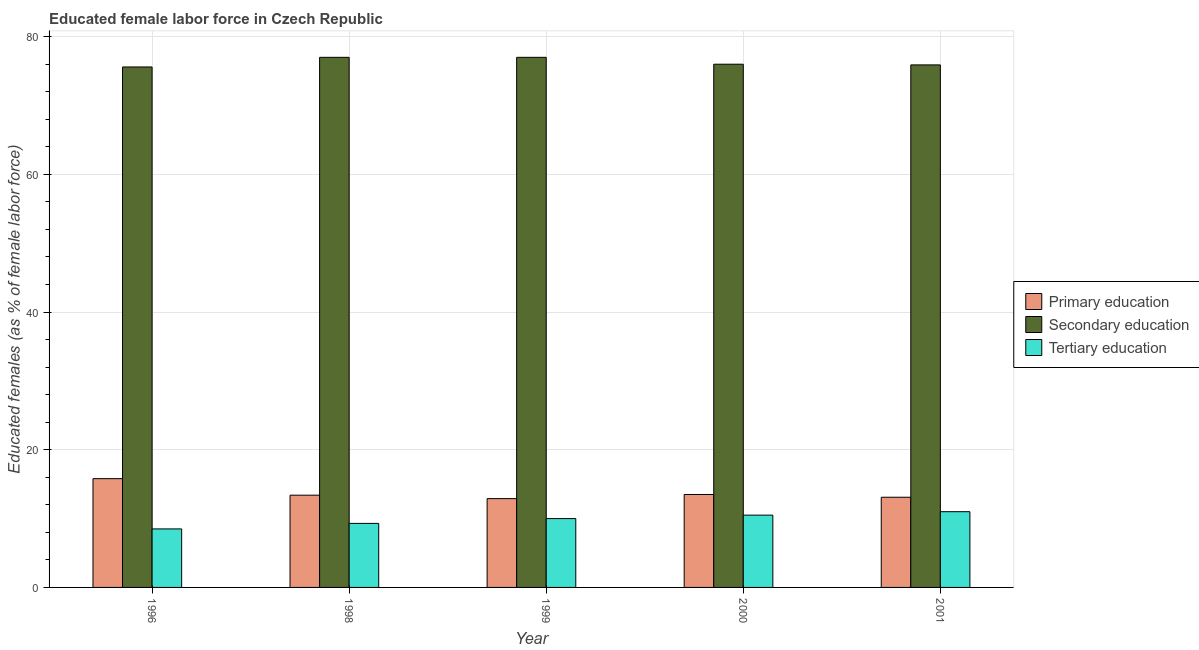How many different coloured bars are there?
Keep it short and to the point. 3. How many groups of bars are there?
Provide a succinct answer. 5. How many bars are there on the 4th tick from the left?
Your answer should be compact. 3. In how many cases, is the number of bars for a given year not equal to the number of legend labels?
Offer a terse response. 0. Across all years, what is the maximum percentage of female labor force who received primary education?
Provide a short and direct response. 15.8. Across all years, what is the minimum percentage of female labor force who received secondary education?
Offer a very short reply. 75.6. What is the total percentage of female labor force who received tertiary education in the graph?
Give a very brief answer. 49.3. What is the difference between the percentage of female labor force who received primary education in 1996 and that in 1998?
Make the answer very short. 2.4. What is the difference between the percentage of female labor force who received tertiary education in 1996 and the percentage of female labor force who received secondary education in 1998?
Your answer should be very brief. -0.8. What is the average percentage of female labor force who received secondary education per year?
Your response must be concise. 76.3. In the year 1996, what is the difference between the percentage of female labor force who received primary education and percentage of female labor force who received tertiary education?
Provide a short and direct response. 0. In how many years, is the percentage of female labor force who received secondary education greater than 16 %?
Give a very brief answer. 5. Is the percentage of female labor force who received primary education in 1999 less than that in 2001?
Ensure brevity in your answer.  Yes. Is the difference between the percentage of female labor force who received secondary education in 1999 and 2001 greater than the difference between the percentage of female labor force who received tertiary education in 1999 and 2001?
Provide a succinct answer. No. What is the difference between the highest and the lowest percentage of female labor force who received tertiary education?
Your response must be concise. 2.5. What does the 2nd bar from the left in 1998 represents?
Your answer should be compact. Secondary education. Are all the bars in the graph horizontal?
Your answer should be very brief. No. Does the graph contain any zero values?
Your response must be concise. No. Where does the legend appear in the graph?
Offer a terse response. Center right. How many legend labels are there?
Your response must be concise. 3. What is the title of the graph?
Provide a short and direct response. Educated female labor force in Czech Republic. Does "Ireland" appear as one of the legend labels in the graph?
Your answer should be compact. No. What is the label or title of the X-axis?
Ensure brevity in your answer.  Year. What is the label or title of the Y-axis?
Provide a short and direct response. Educated females (as % of female labor force). What is the Educated females (as % of female labor force) in Primary education in 1996?
Make the answer very short. 15.8. What is the Educated females (as % of female labor force) in Secondary education in 1996?
Your answer should be compact. 75.6. What is the Educated females (as % of female labor force) of Primary education in 1998?
Keep it short and to the point. 13.4. What is the Educated females (as % of female labor force) of Secondary education in 1998?
Offer a very short reply. 77. What is the Educated females (as % of female labor force) in Tertiary education in 1998?
Your answer should be very brief. 9.3. What is the Educated females (as % of female labor force) of Primary education in 1999?
Provide a succinct answer. 12.9. What is the Educated females (as % of female labor force) of Tertiary education in 1999?
Your answer should be very brief. 10. What is the Educated females (as % of female labor force) of Primary education in 2000?
Your answer should be very brief. 13.5. What is the Educated females (as % of female labor force) of Tertiary education in 2000?
Keep it short and to the point. 10.5. What is the Educated females (as % of female labor force) of Primary education in 2001?
Provide a succinct answer. 13.1. What is the Educated females (as % of female labor force) of Secondary education in 2001?
Ensure brevity in your answer.  75.9. Across all years, what is the maximum Educated females (as % of female labor force) of Primary education?
Your answer should be very brief. 15.8. Across all years, what is the maximum Educated females (as % of female labor force) in Secondary education?
Make the answer very short. 77. Across all years, what is the maximum Educated females (as % of female labor force) of Tertiary education?
Offer a very short reply. 11. Across all years, what is the minimum Educated females (as % of female labor force) in Primary education?
Your response must be concise. 12.9. Across all years, what is the minimum Educated females (as % of female labor force) in Secondary education?
Keep it short and to the point. 75.6. What is the total Educated females (as % of female labor force) in Primary education in the graph?
Offer a terse response. 68.7. What is the total Educated females (as % of female labor force) in Secondary education in the graph?
Your answer should be very brief. 381.5. What is the total Educated females (as % of female labor force) of Tertiary education in the graph?
Offer a very short reply. 49.3. What is the difference between the Educated females (as % of female labor force) in Secondary education in 1996 and that in 1999?
Provide a short and direct response. -1.4. What is the difference between the Educated females (as % of female labor force) in Secondary education in 1996 and that in 2000?
Provide a short and direct response. -0.4. What is the difference between the Educated females (as % of female labor force) of Primary education in 1996 and that in 2001?
Keep it short and to the point. 2.7. What is the difference between the Educated females (as % of female labor force) in Secondary education in 1996 and that in 2001?
Make the answer very short. -0.3. What is the difference between the Educated females (as % of female labor force) of Tertiary education in 1996 and that in 2001?
Your response must be concise. -2.5. What is the difference between the Educated females (as % of female labor force) in Primary education in 1998 and that in 1999?
Ensure brevity in your answer.  0.5. What is the difference between the Educated females (as % of female labor force) in Primary education in 1998 and that in 2000?
Make the answer very short. -0.1. What is the difference between the Educated females (as % of female labor force) in Tertiary education in 1998 and that in 2000?
Ensure brevity in your answer.  -1.2. What is the difference between the Educated females (as % of female labor force) of Secondary education in 1999 and that in 2001?
Provide a short and direct response. 1.1. What is the difference between the Educated females (as % of female labor force) in Tertiary education in 1999 and that in 2001?
Your answer should be compact. -1. What is the difference between the Educated females (as % of female labor force) in Primary education in 2000 and that in 2001?
Provide a succinct answer. 0.4. What is the difference between the Educated females (as % of female labor force) of Tertiary education in 2000 and that in 2001?
Your answer should be very brief. -0.5. What is the difference between the Educated females (as % of female labor force) in Primary education in 1996 and the Educated females (as % of female labor force) in Secondary education in 1998?
Ensure brevity in your answer.  -61.2. What is the difference between the Educated females (as % of female labor force) in Primary education in 1996 and the Educated females (as % of female labor force) in Tertiary education in 1998?
Offer a very short reply. 6.5. What is the difference between the Educated females (as % of female labor force) of Secondary education in 1996 and the Educated females (as % of female labor force) of Tertiary education in 1998?
Offer a very short reply. 66.3. What is the difference between the Educated females (as % of female labor force) in Primary education in 1996 and the Educated females (as % of female labor force) in Secondary education in 1999?
Give a very brief answer. -61.2. What is the difference between the Educated females (as % of female labor force) in Secondary education in 1996 and the Educated females (as % of female labor force) in Tertiary education in 1999?
Your response must be concise. 65.6. What is the difference between the Educated females (as % of female labor force) of Primary education in 1996 and the Educated females (as % of female labor force) of Secondary education in 2000?
Your response must be concise. -60.2. What is the difference between the Educated females (as % of female labor force) in Primary education in 1996 and the Educated females (as % of female labor force) in Tertiary education in 2000?
Ensure brevity in your answer.  5.3. What is the difference between the Educated females (as % of female labor force) of Secondary education in 1996 and the Educated females (as % of female labor force) of Tertiary education in 2000?
Offer a terse response. 65.1. What is the difference between the Educated females (as % of female labor force) in Primary education in 1996 and the Educated females (as % of female labor force) in Secondary education in 2001?
Keep it short and to the point. -60.1. What is the difference between the Educated females (as % of female labor force) in Secondary education in 1996 and the Educated females (as % of female labor force) in Tertiary education in 2001?
Make the answer very short. 64.6. What is the difference between the Educated females (as % of female labor force) of Primary education in 1998 and the Educated females (as % of female labor force) of Secondary education in 1999?
Give a very brief answer. -63.6. What is the difference between the Educated females (as % of female labor force) of Primary education in 1998 and the Educated females (as % of female labor force) of Tertiary education in 1999?
Give a very brief answer. 3.4. What is the difference between the Educated females (as % of female labor force) in Primary education in 1998 and the Educated females (as % of female labor force) in Secondary education in 2000?
Keep it short and to the point. -62.6. What is the difference between the Educated females (as % of female labor force) of Primary education in 1998 and the Educated females (as % of female labor force) of Tertiary education in 2000?
Keep it short and to the point. 2.9. What is the difference between the Educated females (as % of female labor force) in Secondary education in 1998 and the Educated females (as % of female labor force) in Tertiary education in 2000?
Offer a terse response. 66.5. What is the difference between the Educated females (as % of female labor force) in Primary education in 1998 and the Educated females (as % of female labor force) in Secondary education in 2001?
Your answer should be compact. -62.5. What is the difference between the Educated females (as % of female labor force) of Secondary education in 1998 and the Educated females (as % of female labor force) of Tertiary education in 2001?
Ensure brevity in your answer.  66. What is the difference between the Educated females (as % of female labor force) in Primary education in 1999 and the Educated females (as % of female labor force) in Secondary education in 2000?
Ensure brevity in your answer.  -63.1. What is the difference between the Educated females (as % of female labor force) in Primary education in 1999 and the Educated females (as % of female labor force) in Tertiary education in 2000?
Provide a short and direct response. 2.4. What is the difference between the Educated females (as % of female labor force) in Secondary education in 1999 and the Educated females (as % of female labor force) in Tertiary education in 2000?
Offer a terse response. 66.5. What is the difference between the Educated females (as % of female labor force) in Primary education in 1999 and the Educated females (as % of female labor force) in Secondary education in 2001?
Your answer should be very brief. -63. What is the difference between the Educated females (as % of female labor force) of Primary education in 2000 and the Educated females (as % of female labor force) of Secondary education in 2001?
Give a very brief answer. -62.4. What is the difference between the Educated females (as % of female labor force) of Secondary education in 2000 and the Educated females (as % of female labor force) of Tertiary education in 2001?
Provide a short and direct response. 65. What is the average Educated females (as % of female labor force) in Primary education per year?
Provide a short and direct response. 13.74. What is the average Educated females (as % of female labor force) of Secondary education per year?
Your answer should be very brief. 76.3. What is the average Educated females (as % of female labor force) in Tertiary education per year?
Ensure brevity in your answer.  9.86. In the year 1996, what is the difference between the Educated females (as % of female labor force) in Primary education and Educated females (as % of female labor force) in Secondary education?
Offer a very short reply. -59.8. In the year 1996, what is the difference between the Educated females (as % of female labor force) in Secondary education and Educated females (as % of female labor force) in Tertiary education?
Make the answer very short. 67.1. In the year 1998, what is the difference between the Educated females (as % of female labor force) in Primary education and Educated females (as % of female labor force) in Secondary education?
Make the answer very short. -63.6. In the year 1998, what is the difference between the Educated females (as % of female labor force) of Primary education and Educated females (as % of female labor force) of Tertiary education?
Provide a short and direct response. 4.1. In the year 1998, what is the difference between the Educated females (as % of female labor force) in Secondary education and Educated females (as % of female labor force) in Tertiary education?
Your answer should be very brief. 67.7. In the year 1999, what is the difference between the Educated females (as % of female labor force) of Primary education and Educated females (as % of female labor force) of Secondary education?
Provide a succinct answer. -64.1. In the year 1999, what is the difference between the Educated females (as % of female labor force) of Secondary education and Educated females (as % of female labor force) of Tertiary education?
Ensure brevity in your answer.  67. In the year 2000, what is the difference between the Educated females (as % of female labor force) of Primary education and Educated females (as % of female labor force) of Secondary education?
Provide a succinct answer. -62.5. In the year 2000, what is the difference between the Educated females (as % of female labor force) in Primary education and Educated females (as % of female labor force) in Tertiary education?
Your response must be concise. 3. In the year 2000, what is the difference between the Educated females (as % of female labor force) of Secondary education and Educated females (as % of female labor force) of Tertiary education?
Offer a terse response. 65.5. In the year 2001, what is the difference between the Educated females (as % of female labor force) in Primary education and Educated females (as % of female labor force) in Secondary education?
Keep it short and to the point. -62.8. In the year 2001, what is the difference between the Educated females (as % of female labor force) of Secondary education and Educated females (as % of female labor force) of Tertiary education?
Ensure brevity in your answer.  64.9. What is the ratio of the Educated females (as % of female labor force) of Primary education in 1996 to that in 1998?
Your response must be concise. 1.18. What is the ratio of the Educated females (as % of female labor force) in Secondary education in 1996 to that in 1998?
Your response must be concise. 0.98. What is the ratio of the Educated females (as % of female labor force) of Tertiary education in 1996 to that in 1998?
Provide a succinct answer. 0.91. What is the ratio of the Educated females (as % of female labor force) in Primary education in 1996 to that in 1999?
Provide a succinct answer. 1.22. What is the ratio of the Educated females (as % of female labor force) of Secondary education in 1996 to that in 1999?
Provide a short and direct response. 0.98. What is the ratio of the Educated females (as % of female labor force) of Primary education in 1996 to that in 2000?
Offer a very short reply. 1.17. What is the ratio of the Educated females (as % of female labor force) in Tertiary education in 1996 to that in 2000?
Provide a short and direct response. 0.81. What is the ratio of the Educated females (as % of female labor force) of Primary education in 1996 to that in 2001?
Ensure brevity in your answer.  1.21. What is the ratio of the Educated females (as % of female labor force) in Tertiary education in 1996 to that in 2001?
Ensure brevity in your answer.  0.77. What is the ratio of the Educated females (as % of female labor force) of Primary education in 1998 to that in 1999?
Offer a terse response. 1.04. What is the ratio of the Educated females (as % of female labor force) of Secondary education in 1998 to that in 2000?
Provide a succinct answer. 1.01. What is the ratio of the Educated females (as % of female labor force) in Tertiary education in 1998 to that in 2000?
Give a very brief answer. 0.89. What is the ratio of the Educated females (as % of female labor force) in Primary education in 1998 to that in 2001?
Provide a short and direct response. 1.02. What is the ratio of the Educated females (as % of female labor force) in Secondary education in 1998 to that in 2001?
Your answer should be very brief. 1.01. What is the ratio of the Educated females (as % of female labor force) of Tertiary education in 1998 to that in 2001?
Offer a very short reply. 0.85. What is the ratio of the Educated females (as % of female labor force) of Primary education in 1999 to that in 2000?
Provide a succinct answer. 0.96. What is the ratio of the Educated females (as % of female labor force) of Secondary education in 1999 to that in 2000?
Your response must be concise. 1.01. What is the ratio of the Educated females (as % of female labor force) in Tertiary education in 1999 to that in 2000?
Make the answer very short. 0.95. What is the ratio of the Educated females (as % of female labor force) in Primary education in 1999 to that in 2001?
Ensure brevity in your answer.  0.98. What is the ratio of the Educated females (as % of female labor force) of Secondary education in 1999 to that in 2001?
Offer a terse response. 1.01. What is the ratio of the Educated females (as % of female labor force) in Tertiary education in 1999 to that in 2001?
Provide a short and direct response. 0.91. What is the ratio of the Educated females (as % of female labor force) in Primary education in 2000 to that in 2001?
Your answer should be very brief. 1.03. What is the ratio of the Educated females (as % of female labor force) of Secondary education in 2000 to that in 2001?
Offer a very short reply. 1. What is the ratio of the Educated females (as % of female labor force) of Tertiary education in 2000 to that in 2001?
Offer a very short reply. 0.95. What is the difference between the highest and the second highest Educated females (as % of female labor force) in Tertiary education?
Make the answer very short. 0.5. What is the difference between the highest and the lowest Educated females (as % of female labor force) of Secondary education?
Provide a succinct answer. 1.4. What is the difference between the highest and the lowest Educated females (as % of female labor force) in Tertiary education?
Offer a very short reply. 2.5. 